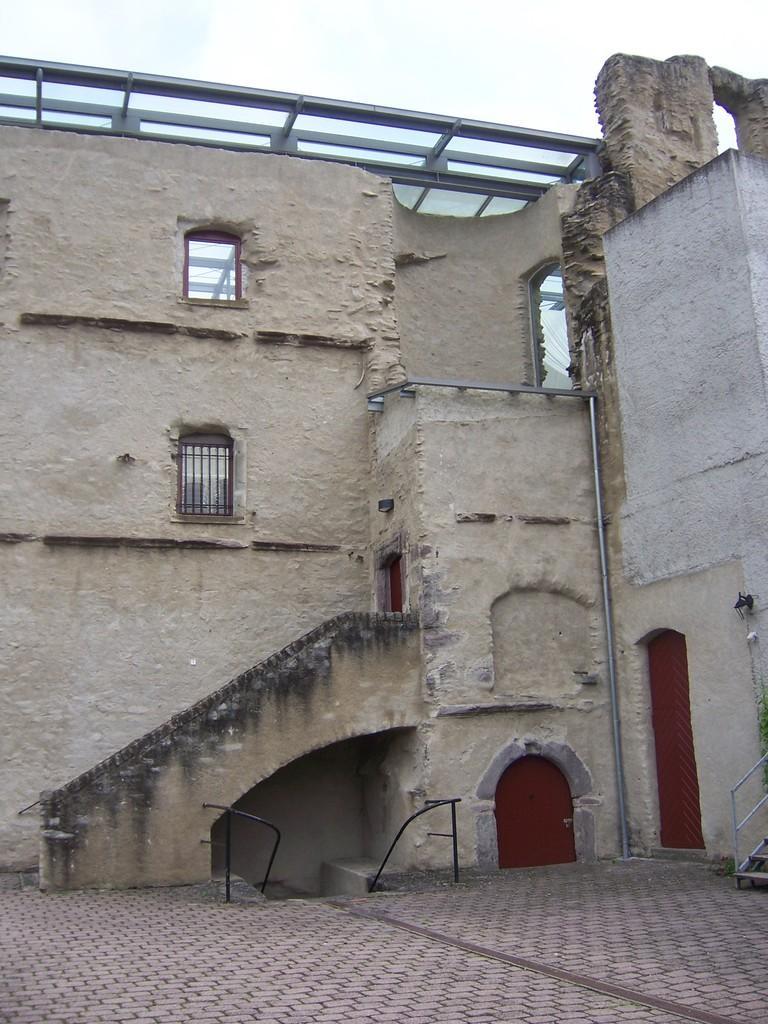Please provide a concise description of this image. In this image I can see there is a ground. On the ground there is a building with doors and a rooftop. And there are stair and a sky. 